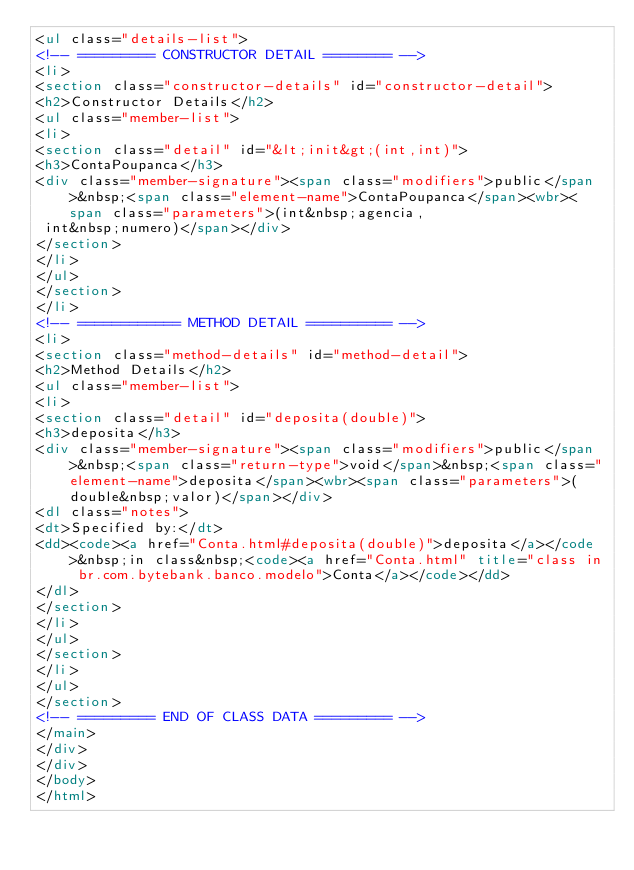Convert code to text. <code><loc_0><loc_0><loc_500><loc_500><_HTML_><ul class="details-list">
<!-- ========= CONSTRUCTOR DETAIL ======== -->
<li>
<section class="constructor-details" id="constructor-detail">
<h2>Constructor Details</h2>
<ul class="member-list">
<li>
<section class="detail" id="&lt;init&gt;(int,int)">
<h3>ContaPoupanca</h3>
<div class="member-signature"><span class="modifiers">public</span>&nbsp;<span class="element-name">ContaPoupanca</span><wbr><span class="parameters">(int&nbsp;agencia,
 int&nbsp;numero)</span></div>
</section>
</li>
</ul>
</section>
</li>
<!-- ============ METHOD DETAIL ========== -->
<li>
<section class="method-details" id="method-detail">
<h2>Method Details</h2>
<ul class="member-list">
<li>
<section class="detail" id="deposita(double)">
<h3>deposita</h3>
<div class="member-signature"><span class="modifiers">public</span>&nbsp;<span class="return-type">void</span>&nbsp;<span class="element-name">deposita</span><wbr><span class="parameters">(double&nbsp;valor)</span></div>
<dl class="notes">
<dt>Specified by:</dt>
<dd><code><a href="Conta.html#deposita(double)">deposita</a></code>&nbsp;in class&nbsp;<code><a href="Conta.html" title="class in br.com.bytebank.banco.modelo">Conta</a></code></dd>
</dl>
</section>
</li>
</ul>
</section>
</li>
</ul>
</section>
<!-- ========= END OF CLASS DATA ========= -->
</main>
</div>
</div>
</body>
</html>
</code> 